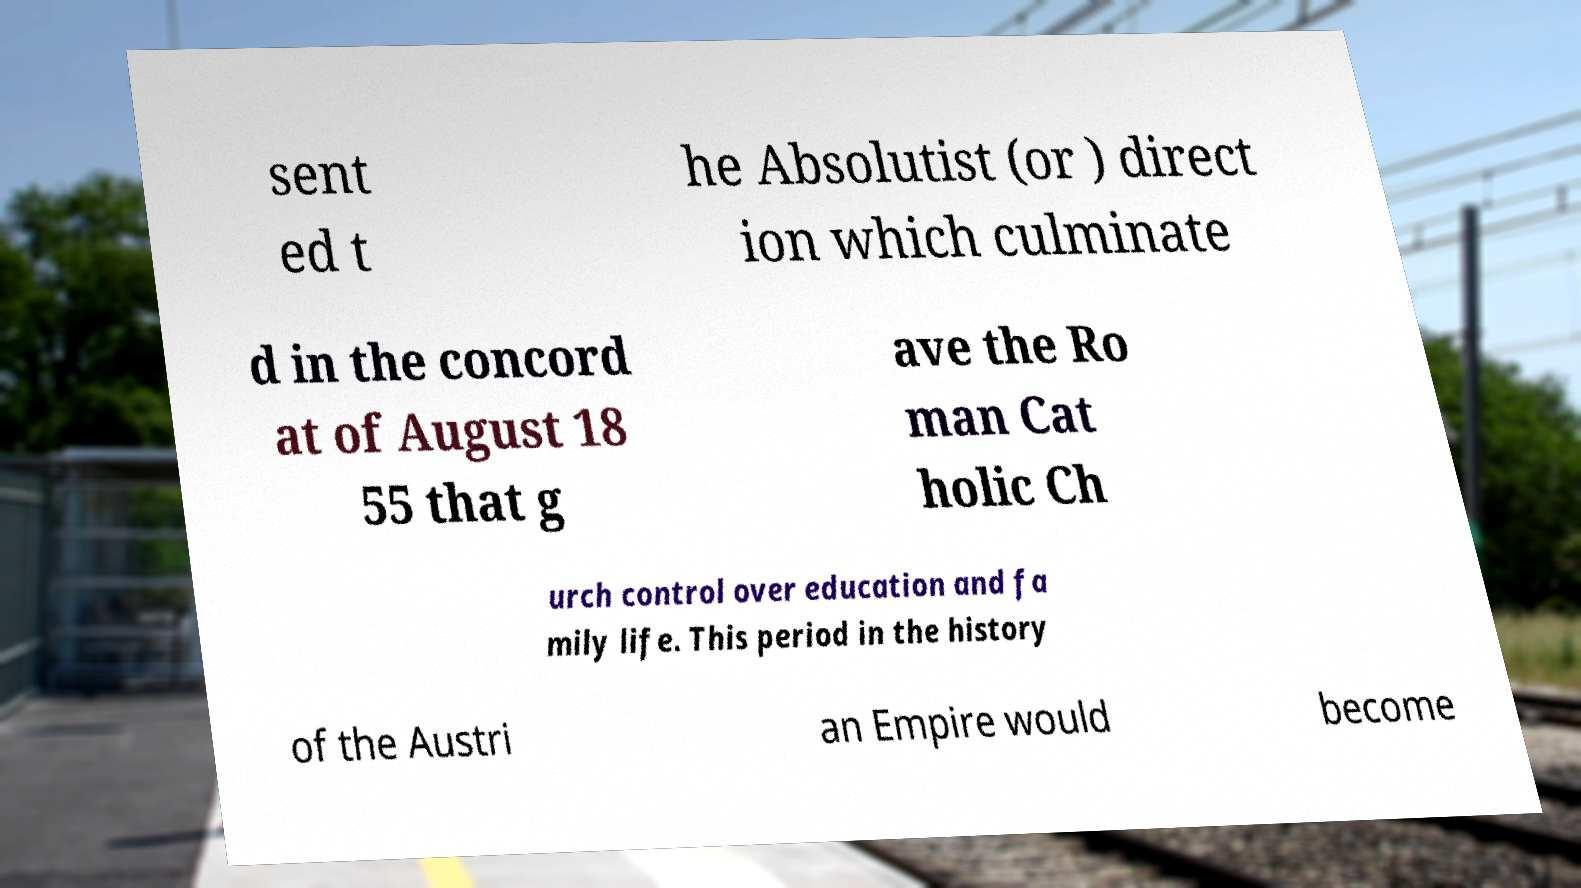There's text embedded in this image that I need extracted. Can you transcribe it verbatim? sent ed t he Absolutist (or ) direct ion which culminate d in the concord at of August 18 55 that g ave the Ro man Cat holic Ch urch control over education and fa mily life. This period in the history of the Austri an Empire would become 